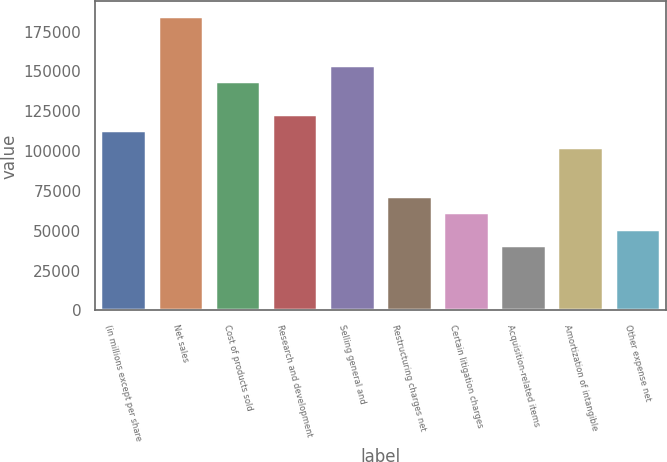<chart> <loc_0><loc_0><loc_500><loc_500><bar_chart><fcel>(in millions except per share<fcel>Net sales<fcel>Cost of products sold<fcel>Research and development<fcel>Selling general and<fcel>Restructuring charges net<fcel>Certain litigation charges<fcel>Acquisition-related items<fcel>Amortization of intangible<fcel>Other expense net<nl><fcel>112957<fcel>184837<fcel>143763<fcel>123225<fcel>154031<fcel>71882.1<fcel>61613.5<fcel>41076.2<fcel>102688<fcel>51344.9<nl></chart> 